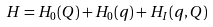Convert formula to latex. <formula><loc_0><loc_0><loc_500><loc_500>H = H _ { 0 } ( Q ) + H _ { 0 } ( q ) + H _ { I } ( q , Q )</formula> 